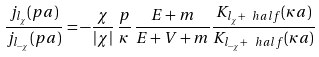<formula> <loc_0><loc_0><loc_500><loc_500>\frac { j _ { l _ { \chi } } ( p a ) } { j _ { l _ { - \chi } } ( p a ) } = - \frac { \chi } { | \chi | } \, \frac { p } { \kappa } \, \frac { E + m } { E + V + m } \frac { K _ { l _ { \chi } + \ h a l f } ( \kappa a ) } { K _ { l _ { - \chi } + \ h a l f } ( \kappa a ) }</formula> 